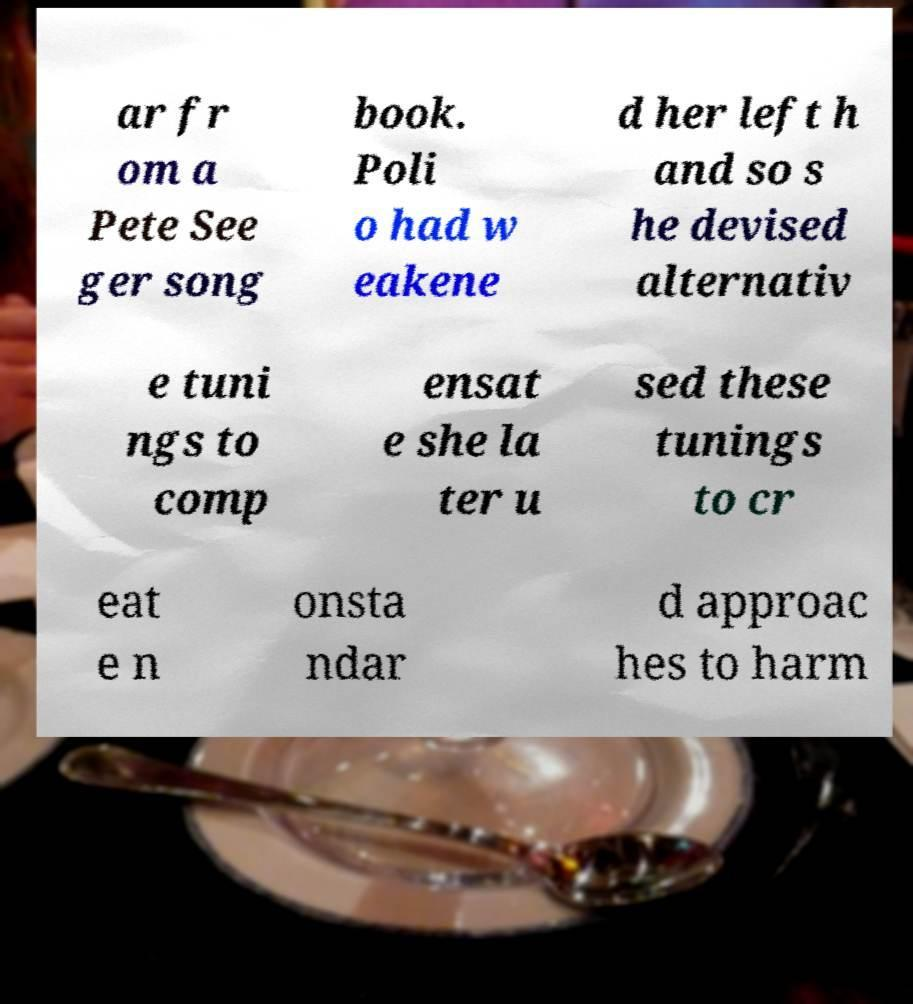I need the written content from this picture converted into text. Can you do that? ar fr om a Pete See ger song book. Poli o had w eakene d her left h and so s he devised alternativ e tuni ngs to comp ensat e she la ter u sed these tunings to cr eat e n onsta ndar d approac hes to harm 